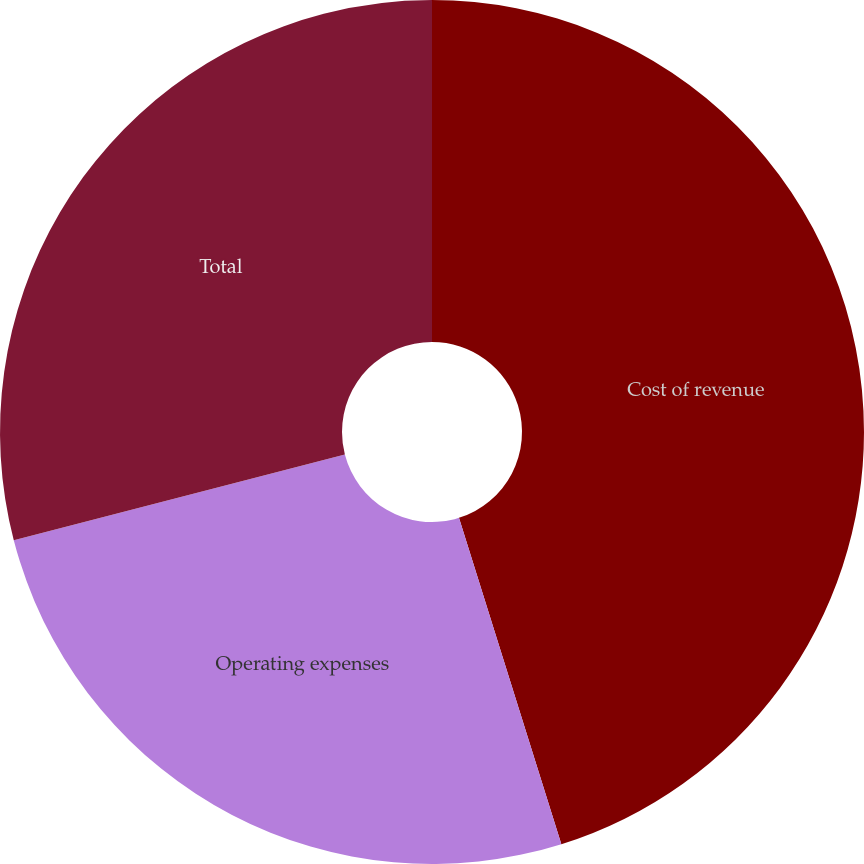<chart> <loc_0><loc_0><loc_500><loc_500><pie_chart><fcel>Cost of revenue<fcel>Operating expenses<fcel>Total<nl><fcel>45.16%<fcel>25.81%<fcel>29.03%<nl></chart> 